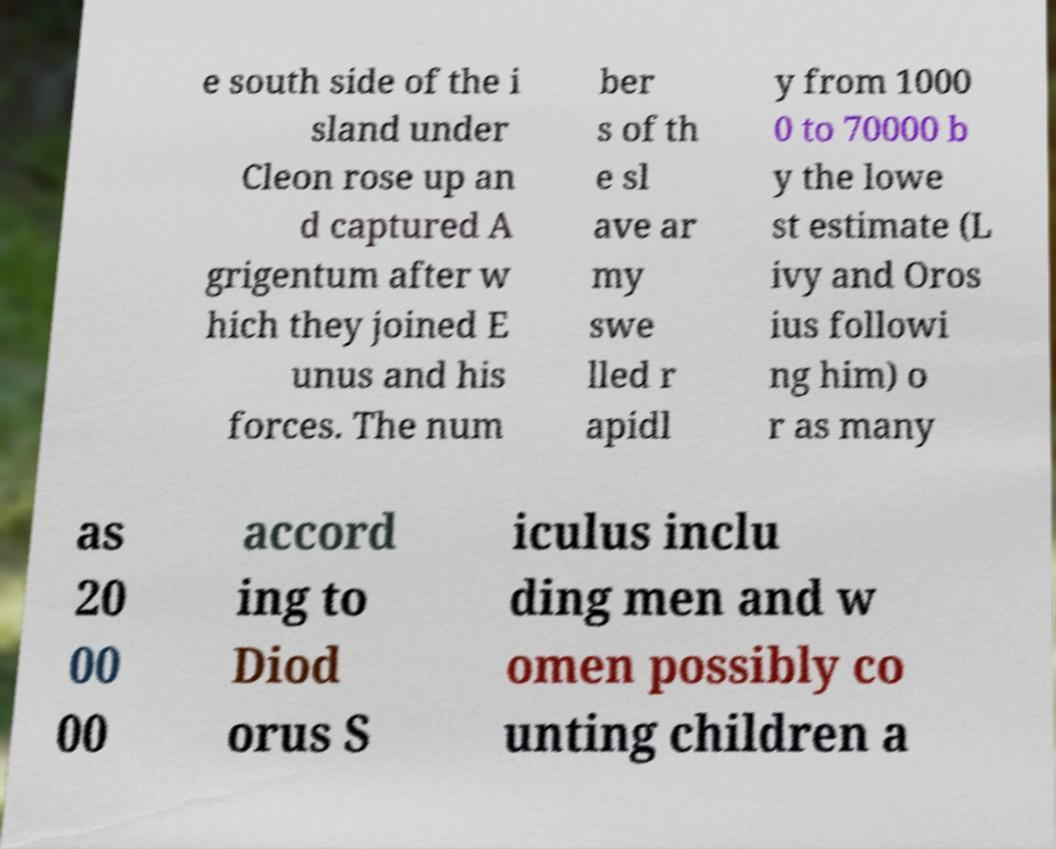Could you extract and type out the text from this image? e south side of the i sland under Cleon rose up an d captured A grigentum after w hich they joined E unus and his forces. The num ber s of th e sl ave ar my swe lled r apidl y from 1000 0 to 70000 b y the lowe st estimate (L ivy and Oros ius followi ng him) o r as many as 20 00 00 accord ing to Diod orus S iculus inclu ding men and w omen possibly co unting children a 